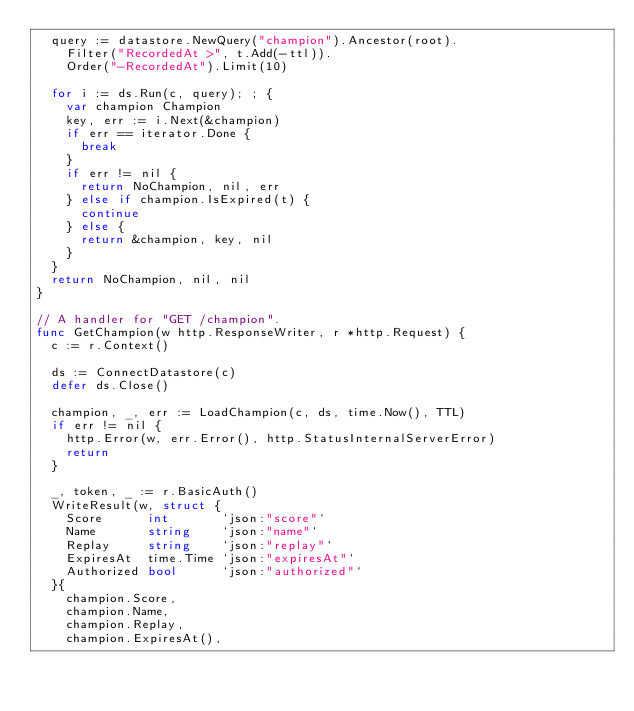<code> <loc_0><loc_0><loc_500><loc_500><_Go_>	query := datastore.NewQuery("champion").Ancestor(root).
		Filter("RecordedAt >", t.Add(-ttl)).
		Order("-RecordedAt").Limit(10)

	for i := ds.Run(c, query); ; {
		var champion Champion
		key, err := i.Next(&champion)
		if err == iterator.Done {
			break
		}
		if err != nil {
			return NoChampion, nil, err
		} else if champion.IsExpired(t) {
			continue
		} else {
			return &champion, key, nil
		}
	}
	return NoChampion, nil, nil
}

// A handler for "GET /champion".
func GetChampion(w http.ResponseWriter, r *http.Request) {
	c := r.Context()

	ds := ConnectDatastore(c)
	defer ds.Close()

	champion, _, err := LoadChampion(c, ds, time.Now(), TTL)
	if err != nil {
		http.Error(w, err.Error(), http.StatusInternalServerError)
		return
	}

	_, token, _ := r.BasicAuth()
	WriteResult(w, struct {
		Score      int       `json:"score"`
		Name       string    `json:"name"`
		Replay     string    `json:"replay"`
		ExpiresAt  time.Time `json:"expiresAt"`
		Authorized bool      `json:"authorized"`
	}{
		champion.Score,
		champion.Name,
		champion.Replay,
		champion.ExpiresAt(),</code> 